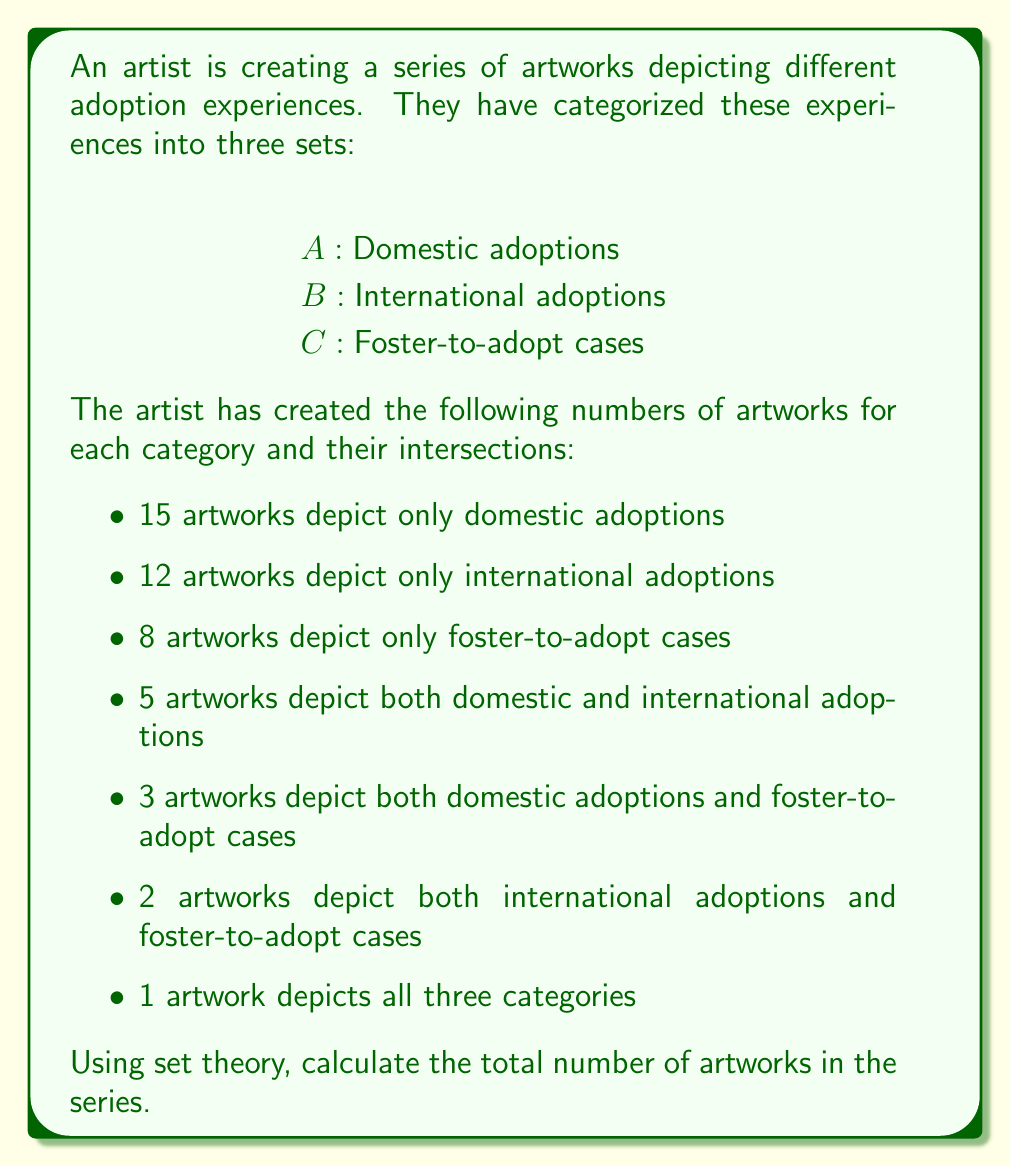Give your solution to this math problem. To solve this problem, we'll use the principle of inclusion-exclusion for three sets. Let's break it down step-by-step:

1. First, let's define our universal set $U$ as all artworks in the series.

2. We can represent the cardinality of each set and their intersections as follows:
   $|A| = 15 + 5 + 3 + 1 = 24$
   $|B| = 12 + 5 + 2 + 1 = 20$
   $|C| = 8 + 3 + 2 + 1 = 14$
   $|A \cap B| = 5 + 1 = 6$
   $|A \cap C| = 3 + 1 = 4$
   $|B \cap C| = 2 + 1 = 3$
   $|A \cap B \cap C| = 1$

3. The principle of inclusion-exclusion for three sets states:

   $|A \cup B \cup C| = |A| + |B| + |C| - |A \cap B| - |A \cap C| - |B \cap C| + |A \cap B \cap C|$

4. Let's substitute our values:

   $|U| = 24 + 20 + 14 - 6 - 4 - 3 + 1$

5. Now we can calculate:

   $|U| = 58 - 13 + 1 = 46$

Therefore, the total number of artworks in the series is 46.
Answer: 46 artworks 